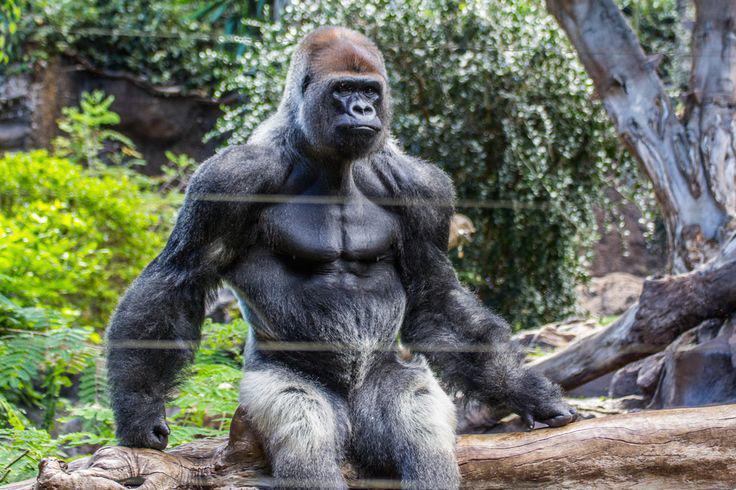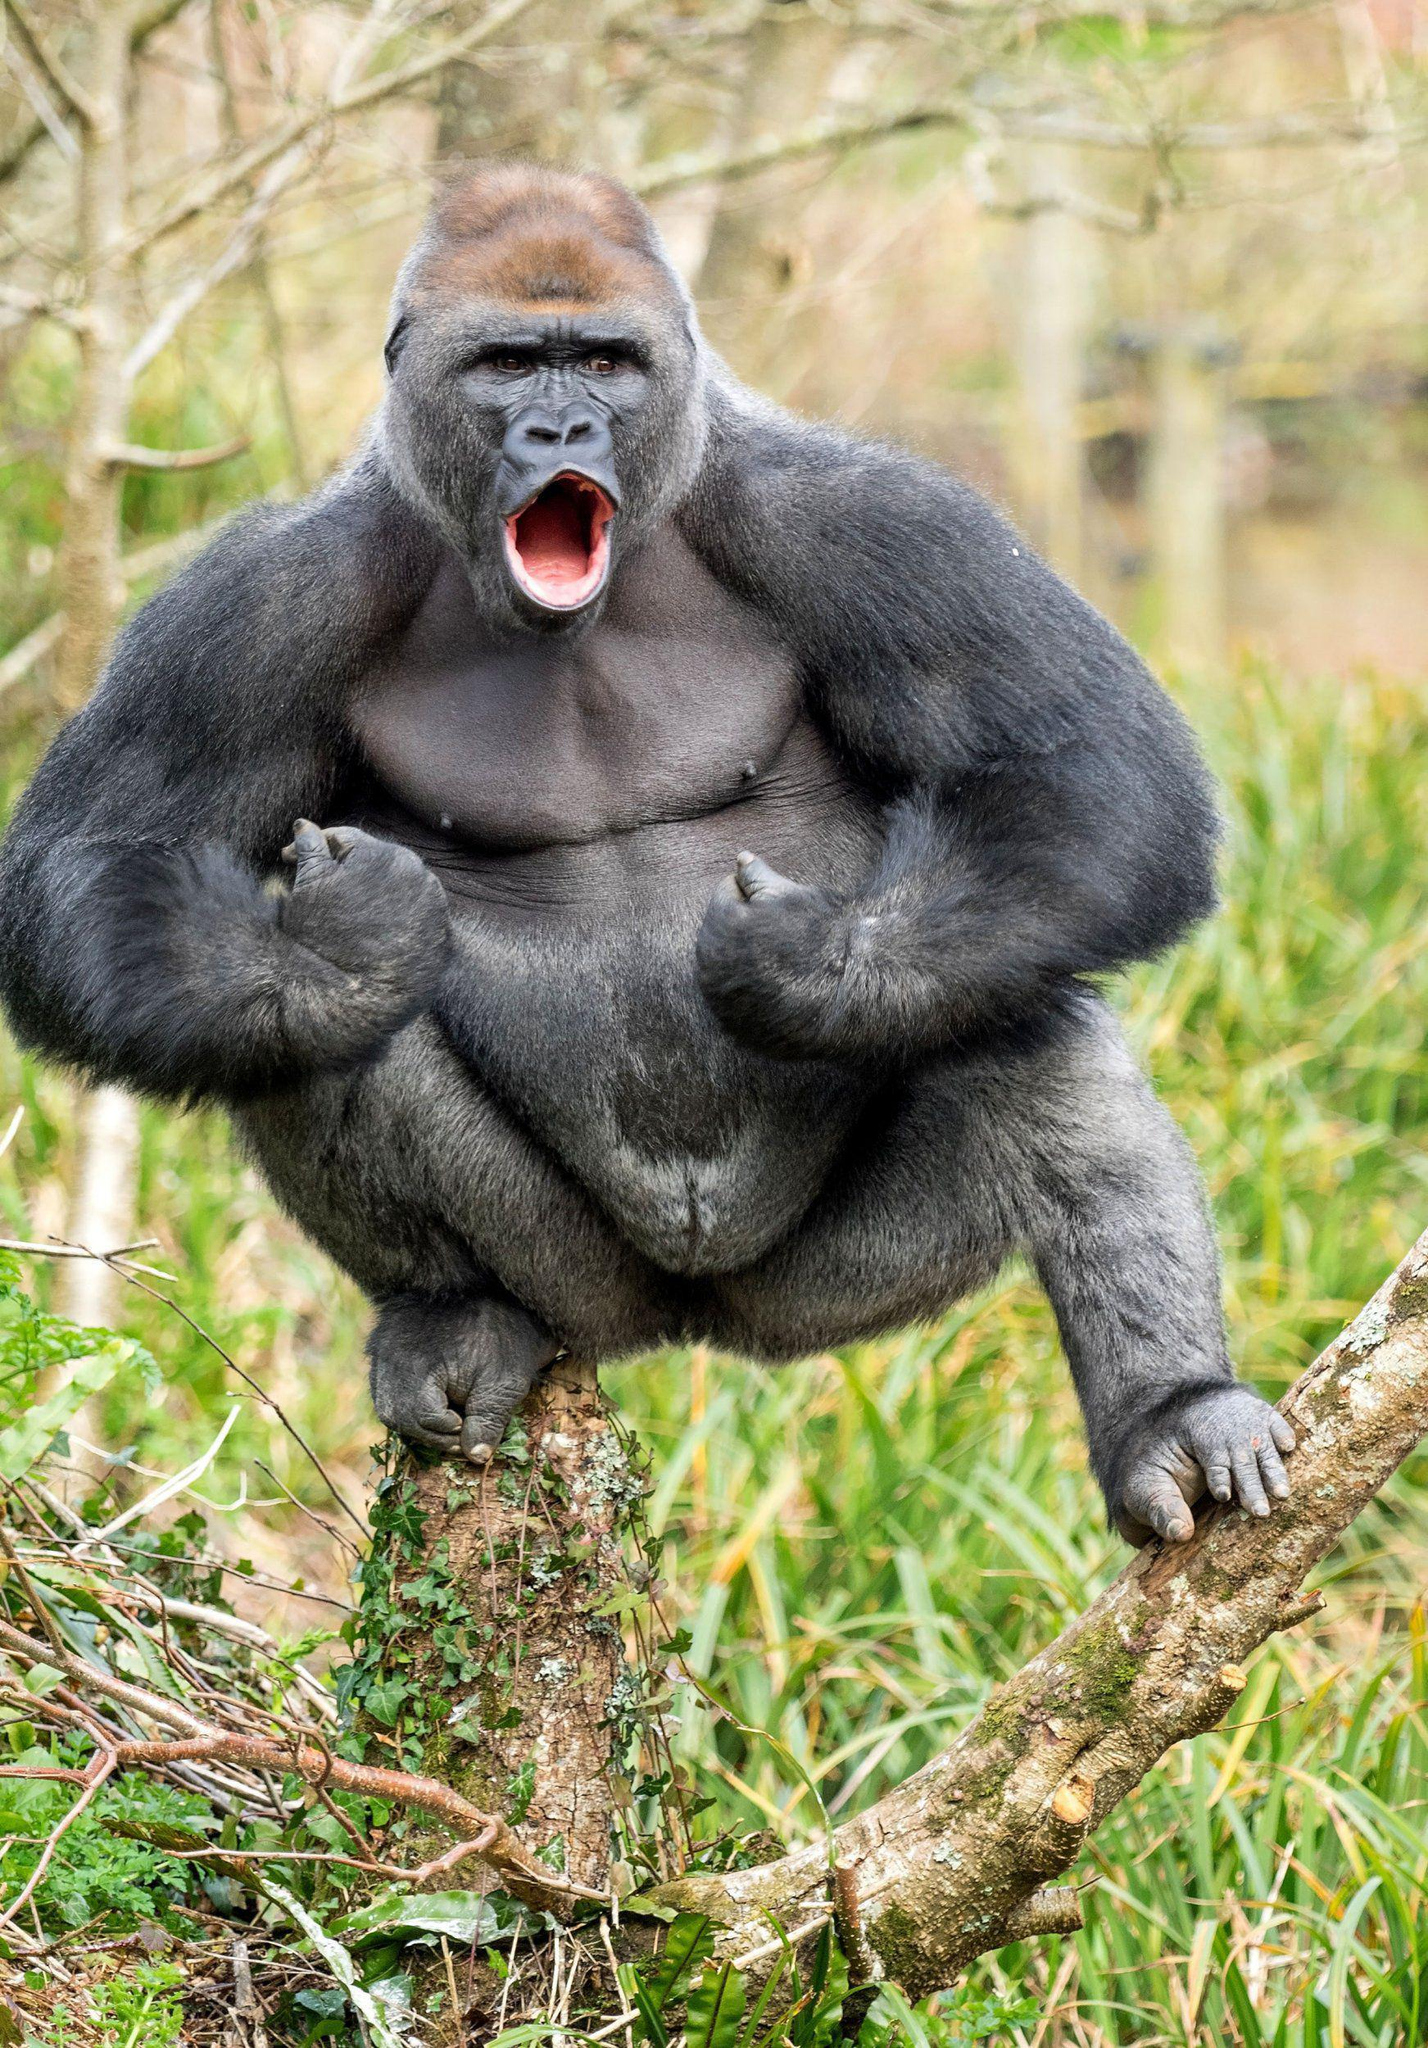The first image is the image on the left, the second image is the image on the right. For the images shown, is this caption "One of the images contains two gorillas that are fighting." true? Answer yes or no. No. 